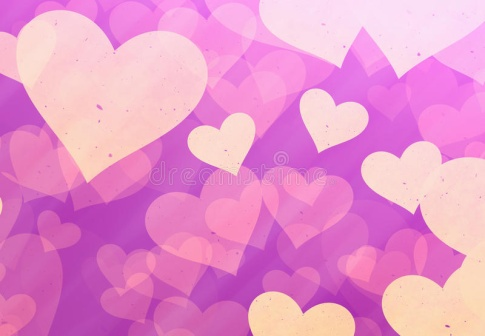Imagine a magical story inspired by this image. In a distant, enchanted realm, this dreamy landscape of hearts and swirling purple skies is known as the Kingdom of Heartclouds. Legend has it that every heart in the sky holds a special wish from the inhabitants of the kingdom, sent aloft by the magical Heartkeeper. One day, a young dreamer named Elara discovered she had the rare ability to read these wishes and bring them to life. Guided by twinkling star-paths and whispers of the Heartkeeper, Elara embarks on a whimsical adventure to fulfill the deepest desires of her fellow dreamers, ultimately uncovering a hidden truth about the power of love and dreams that binds her realm together. What does Elara do if she encounters a wish that conflicts with another? When Elara encounters conflicting wishes, she seeks guidance from the ancient Well of Harmony located at the heart of Heartclouds. The Well, a mystical pool shimmering with countless hues of dreams, provides her with visions of possible outcomes. Elara learns to balance the wishes by finding creative solutions that intertwine the desires harmoniously. For instance, if one wish seeks endless sunlight for joyous gatherings while another longs for gentle rain to nourish the fields, Elara conjures enchanted clouds that lovingly part, allowing both sunshine and rain in perfect harmony, ensuring that both wishes are fulfilled sustainably. Can you describe the daily life in the Kingdom of Heartclouds? Daily life in the Kingdom of Heartclouds is enchanting and filled with joy. The sky above constantly changes in hues, painting a breathtaking backdrop for the residents. Each morning, The Heartkeeper releases new hearts into the sky, and the inhabitants gather in cheerful anticipation, making their wishes and sending them upward. The streets are lined with vibrant flowers that bloom in response to the positive energy of fulfilled wishes. Artisans craft beautiful, floating lanterns that illuminate the evening skies, while children play in fields of soft, rainbow-hued grass. Music and laughter fill the air, as festivals and communal feasts celebrating the magic of love and dreams are common. The community thrives on harmony, creativity, and a shared belief in the power of dreams. 